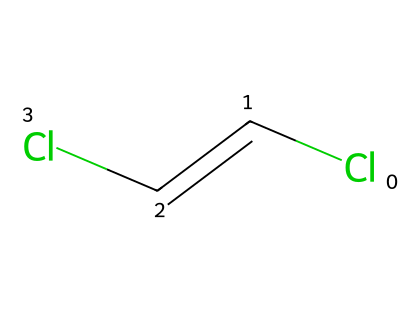What is the molecular formula of dichloroethene? By analyzing the structure, it is clear that there are two carbon atoms (C), two chlorine atoms (Cl), and two hydrogen atoms (H) in the molecule, giving the formula C2H2Cl2.
Answer: C2H2Cl2 How many double bonds are present in this molecule? The structure contains a single double bond between the two carbon atoms (C=C), which is characteristic of alkenes.
Answer: 1 What type of isomers does dichloroethene exhibit? The molecule exhibits geometric isomerism (cis and trans) due to the presence of the double bond and two identical substituents (chlorines) on the carbons.
Answer: geometric isomers What is the boiling point range for the trans isomer of dichloroethene? The trans isomer typically has a higher boiling point compared to the cis isomer, with a range approximately between 47-50 degrees Celsius.
Answer: 47-50 degrees Celsius What effect does the geometry of dichloroethene have on its physical properties? The geometric isomers have different spatial arrangements (cis has chlorine atoms on the same side, trans has them on opposite sides), which affects factors like boiling point, polarity, and solubility.
Answer: different physical properties Which geometric isomer of dichloroethene is more stable? The trans isomer is generally more stable than the cis isomer due to less steric strain between the chlorine atoms when they are positioned further apart.
Answer: trans isomer How many hydrogen atoms are attached to each carbon in the cis isomer of dichloroethene? In the cis isomer, each carbon atom is bonded to one hydrogen atom due to the presence of chlorine substituents, so there is one hydrogen atom per carbon.
Answer: 1 